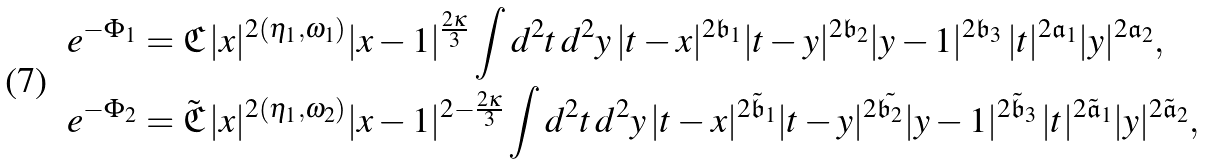<formula> <loc_0><loc_0><loc_500><loc_500>& e ^ { - \Phi _ { 1 } } = \mathfrak { C } \, | x | ^ { 2 ( \eta _ { 1 } , \omega _ { 1 } ) } | x - 1 | ^ { \frac { 2 \kappa } { 3 } } \int d ^ { 2 } t \, d ^ { 2 } y \, | t - x | ^ { 2 \mathfrak { b } _ { 1 } } | t - y | ^ { 2 \mathfrak { b } _ { 2 } } | y - 1 | ^ { 2 \mathfrak { b } _ { 3 } } \, | t | ^ { 2 \mathfrak { a } _ { 1 } } | y | ^ { 2 \mathfrak { a } _ { 2 } } , \\ & e ^ { - \Phi _ { 2 } } = \tilde { \mathfrak { C } } \, | x | ^ { 2 ( \eta _ { 1 } , \omega _ { 2 } ) } | x - 1 | ^ { 2 - \frac { 2 \kappa } { 3 } } \int d ^ { 2 } t \, d ^ { 2 } y \, | t - x | ^ { 2 \tilde { \mathfrak { b } } _ { 1 } } | t - y | ^ { 2 \tilde { \mathfrak { b } _ { 2 } } } | y - 1 | ^ { 2 \tilde { \mathfrak { b } } _ { 3 } } \, | t | ^ { 2 \tilde { \mathfrak { a } } _ { 1 } } | y | ^ { 2 \tilde { \mathfrak { a } } _ { 2 } } ,</formula> 